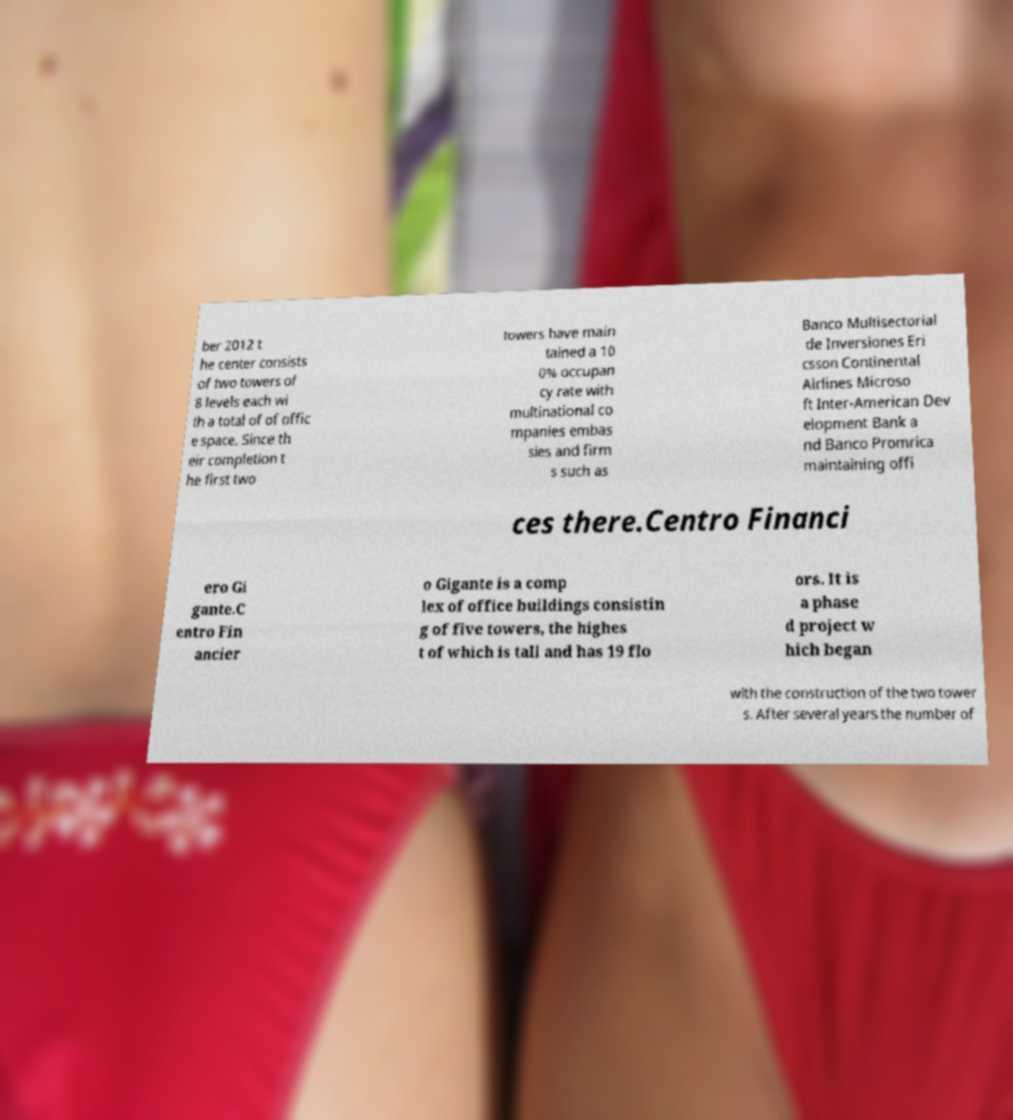Can you read and provide the text displayed in the image?This photo seems to have some interesting text. Can you extract and type it out for me? ber 2012 t he center consists of two towers of 8 levels each wi th a total of of offic e space. Since th eir completion t he first two towers have main tained a 10 0% occupan cy rate with multinational co mpanies embas sies and firm s such as Banco Multisectorial de Inversiones Eri csson Continental Airlines Microso ft Inter-American Dev elopment Bank a nd Banco Promrica maintaining offi ces there.Centro Financi ero Gi gante.C entro Fin ancier o Gigante is a comp lex of office buildings consistin g of five towers, the highes t of which is tall and has 19 flo ors. It is a phase d project w hich began with the construction of the two tower s. After several years the number of 